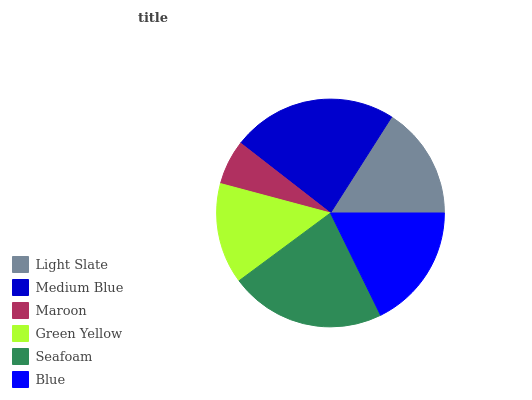Is Maroon the minimum?
Answer yes or no. Yes. Is Medium Blue the maximum?
Answer yes or no. Yes. Is Medium Blue the minimum?
Answer yes or no. No. Is Maroon the maximum?
Answer yes or no. No. Is Medium Blue greater than Maroon?
Answer yes or no. Yes. Is Maroon less than Medium Blue?
Answer yes or no. Yes. Is Maroon greater than Medium Blue?
Answer yes or no. No. Is Medium Blue less than Maroon?
Answer yes or no. No. Is Blue the high median?
Answer yes or no. Yes. Is Light Slate the low median?
Answer yes or no. Yes. Is Seafoam the high median?
Answer yes or no. No. Is Maroon the low median?
Answer yes or no. No. 